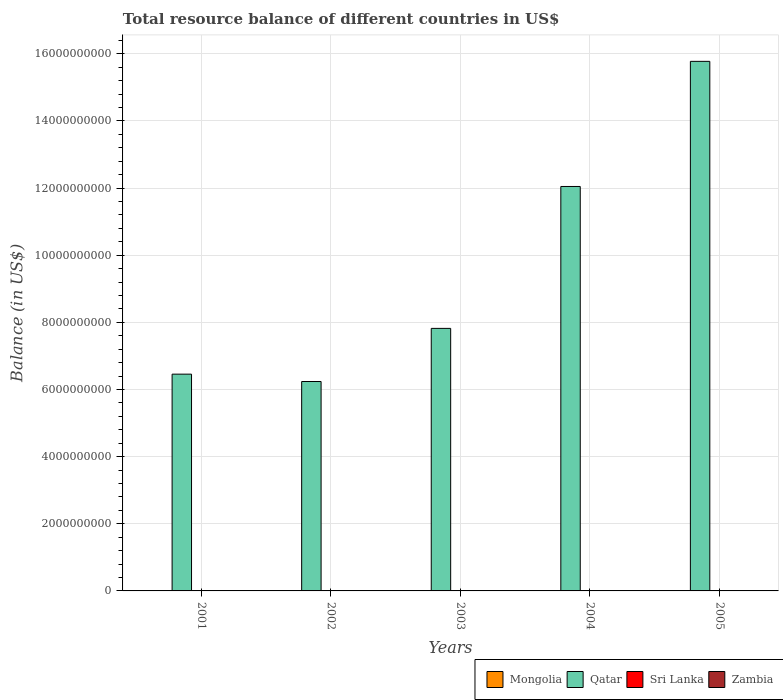Are the number of bars per tick equal to the number of legend labels?
Your answer should be very brief. No. How many bars are there on the 1st tick from the left?
Give a very brief answer. 1. What is the label of the 5th group of bars from the left?
Your response must be concise. 2005. In how many cases, is the number of bars for a given year not equal to the number of legend labels?
Ensure brevity in your answer.  5. What is the total resource balance in Qatar in 2001?
Offer a very short reply. 6.46e+09. Across all years, what is the maximum total resource balance in Qatar?
Provide a short and direct response. 1.58e+1. What is the difference between the total resource balance in Qatar in 2001 and that in 2002?
Offer a terse response. 2.19e+08. What is the difference between the total resource balance in Qatar in 2005 and the total resource balance in Zambia in 2002?
Keep it short and to the point. 1.58e+1. In how many years, is the total resource balance in Zambia greater than 3200000000 US$?
Keep it short and to the point. 0. What is the ratio of the total resource balance in Qatar in 2002 to that in 2003?
Provide a succinct answer. 0.8. Is the total resource balance in Qatar in 2002 less than that in 2003?
Give a very brief answer. Yes. What is the difference between the highest and the second highest total resource balance in Qatar?
Ensure brevity in your answer.  3.73e+09. Is the sum of the total resource balance in Qatar in 2001 and 2003 greater than the maximum total resource balance in Zambia across all years?
Ensure brevity in your answer.  Yes. Is it the case that in every year, the sum of the total resource balance in Mongolia and total resource balance in Qatar is greater than the sum of total resource balance in Zambia and total resource balance in Sri Lanka?
Offer a very short reply. No. Is it the case that in every year, the sum of the total resource balance in Sri Lanka and total resource balance in Qatar is greater than the total resource balance in Zambia?
Provide a succinct answer. Yes. How many bars are there?
Ensure brevity in your answer.  5. Are all the bars in the graph horizontal?
Give a very brief answer. No. What is the difference between two consecutive major ticks on the Y-axis?
Your answer should be very brief. 2.00e+09. Does the graph contain any zero values?
Offer a very short reply. Yes. How many legend labels are there?
Offer a terse response. 4. How are the legend labels stacked?
Your response must be concise. Horizontal. What is the title of the graph?
Make the answer very short. Total resource balance of different countries in US$. Does "Czech Republic" appear as one of the legend labels in the graph?
Your answer should be compact. No. What is the label or title of the Y-axis?
Offer a very short reply. Balance (in US$). What is the Balance (in US$) of Mongolia in 2001?
Ensure brevity in your answer.  0. What is the Balance (in US$) in Qatar in 2001?
Your answer should be very brief. 6.46e+09. What is the Balance (in US$) of Sri Lanka in 2001?
Your answer should be very brief. 0. What is the Balance (in US$) of Zambia in 2001?
Provide a short and direct response. 0. What is the Balance (in US$) of Mongolia in 2002?
Provide a succinct answer. 0. What is the Balance (in US$) of Qatar in 2002?
Ensure brevity in your answer.  6.24e+09. What is the Balance (in US$) of Sri Lanka in 2002?
Keep it short and to the point. 0. What is the Balance (in US$) of Zambia in 2002?
Keep it short and to the point. 0. What is the Balance (in US$) of Qatar in 2003?
Give a very brief answer. 7.82e+09. What is the Balance (in US$) of Sri Lanka in 2003?
Keep it short and to the point. 0. What is the Balance (in US$) of Qatar in 2004?
Make the answer very short. 1.20e+1. What is the Balance (in US$) in Sri Lanka in 2004?
Ensure brevity in your answer.  0. What is the Balance (in US$) of Zambia in 2004?
Your answer should be compact. 0. What is the Balance (in US$) of Mongolia in 2005?
Your answer should be very brief. 0. What is the Balance (in US$) of Qatar in 2005?
Provide a succinct answer. 1.58e+1. What is the Balance (in US$) in Sri Lanka in 2005?
Your answer should be very brief. 0. What is the Balance (in US$) of Zambia in 2005?
Your answer should be compact. 0. Across all years, what is the maximum Balance (in US$) in Qatar?
Your answer should be very brief. 1.58e+1. Across all years, what is the minimum Balance (in US$) of Qatar?
Keep it short and to the point. 6.24e+09. What is the total Balance (in US$) of Mongolia in the graph?
Your response must be concise. 0. What is the total Balance (in US$) of Qatar in the graph?
Offer a very short reply. 4.83e+1. What is the total Balance (in US$) in Zambia in the graph?
Offer a very short reply. 0. What is the difference between the Balance (in US$) in Qatar in 2001 and that in 2002?
Give a very brief answer. 2.19e+08. What is the difference between the Balance (in US$) of Qatar in 2001 and that in 2003?
Offer a very short reply. -1.36e+09. What is the difference between the Balance (in US$) of Qatar in 2001 and that in 2004?
Make the answer very short. -5.59e+09. What is the difference between the Balance (in US$) of Qatar in 2001 and that in 2005?
Give a very brief answer. -9.32e+09. What is the difference between the Balance (in US$) in Qatar in 2002 and that in 2003?
Offer a terse response. -1.58e+09. What is the difference between the Balance (in US$) of Qatar in 2002 and that in 2004?
Ensure brevity in your answer.  -5.81e+09. What is the difference between the Balance (in US$) of Qatar in 2002 and that in 2005?
Provide a short and direct response. -9.54e+09. What is the difference between the Balance (in US$) of Qatar in 2003 and that in 2004?
Your answer should be compact. -4.23e+09. What is the difference between the Balance (in US$) of Qatar in 2003 and that in 2005?
Offer a very short reply. -7.95e+09. What is the difference between the Balance (in US$) of Qatar in 2004 and that in 2005?
Make the answer very short. -3.73e+09. What is the average Balance (in US$) of Mongolia per year?
Your answer should be very brief. 0. What is the average Balance (in US$) in Qatar per year?
Ensure brevity in your answer.  9.67e+09. What is the average Balance (in US$) in Zambia per year?
Give a very brief answer. 0. What is the ratio of the Balance (in US$) in Qatar in 2001 to that in 2002?
Offer a very short reply. 1.04. What is the ratio of the Balance (in US$) in Qatar in 2001 to that in 2003?
Provide a succinct answer. 0.83. What is the ratio of the Balance (in US$) in Qatar in 2001 to that in 2004?
Keep it short and to the point. 0.54. What is the ratio of the Balance (in US$) in Qatar in 2001 to that in 2005?
Your answer should be very brief. 0.41. What is the ratio of the Balance (in US$) of Qatar in 2002 to that in 2003?
Your answer should be compact. 0.8. What is the ratio of the Balance (in US$) of Qatar in 2002 to that in 2004?
Your answer should be very brief. 0.52. What is the ratio of the Balance (in US$) of Qatar in 2002 to that in 2005?
Provide a succinct answer. 0.4. What is the ratio of the Balance (in US$) of Qatar in 2003 to that in 2004?
Make the answer very short. 0.65. What is the ratio of the Balance (in US$) of Qatar in 2003 to that in 2005?
Provide a short and direct response. 0.5. What is the ratio of the Balance (in US$) in Qatar in 2004 to that in 2005?
Offer a very short reply. 0.76. What is the difference between the highest and the second highest Balance (in US$) of Qatar?
Your answer should be compact. 3.73e+09. What is the difference between the highest and the lowest Balance (in US$) in Qatar?
Ensure brevity in your answer.  9.54e+09. 